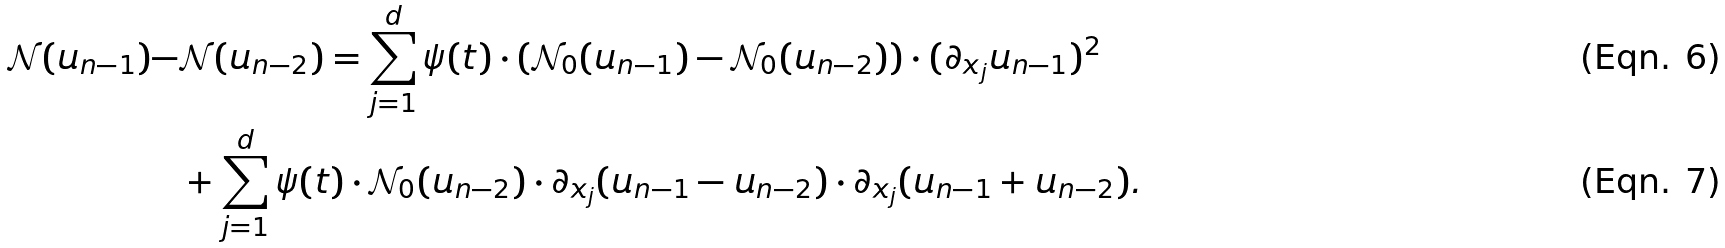Convert formula to latex. <formula><loc_0><loc_0><loc_500><loc_500>\mathcal { N } ( u _ { n - 1 } ) - & \mathcal { N } ( u _ { n - 2 } ) = \sum _ { j = 1 } ^ { d } \psi ( t ) \cdot ( \mathcal { N } _ { 0 } ( u _ { n - 1 } ) - \mathcal { N } _ { 0 } ( u _ { n - 2 } ) ) \cdot ( \partial _ { x _ { j } } u _ { n - 1 } ) ^ { 2 } \\ & + \sum _ { j = 1 } ^ { d } \psi ( t ) \cdot \mathcal { N } _ { 0 } ( u _ { n - 2 } ) \cdot \partial _ { x _ { j } } ( u _ { n - 1 } - u _ { n - 2 } ) \cdot \partial _ { x _ { j } } ( u _ { n - 1 } + u _ { n - 2 } ) .</formula> 